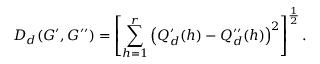<formula> <loc_0><loc_0><loc_500><loc_500>D _ { d } ( G ^ { \prime } , G ^ { \prime \prime } ) = \left [ \sum _ { h = 1 } ^ { r } \left ( Q _ { d } ^ { \prime } ( h ) - Q _ { d } ^ { \prime \prime } ( h ) \right ) ^ { 2 } \right ] ^ { \frac { 1 } { 2 } } .</formula> 